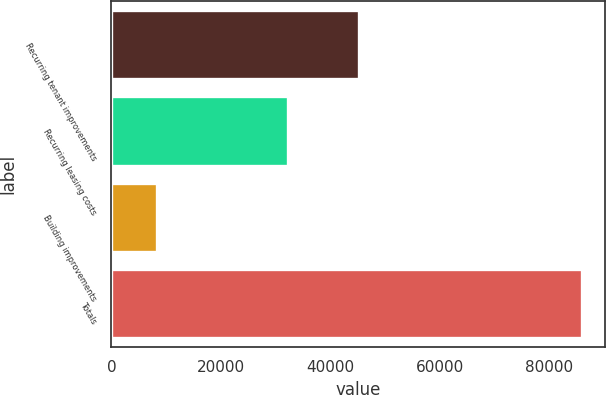Convert chart. <chart><loc_0><loc_0><loc_500><loc_500><bar_chart><fcel>Recurring tenant improvements<fcel>Recurring leasing costs<fcel>Building improvements<fcel>Totals<nl><fcel>45296<fcel>32238<fcel>8402<fcel>85936<nl></chart> 